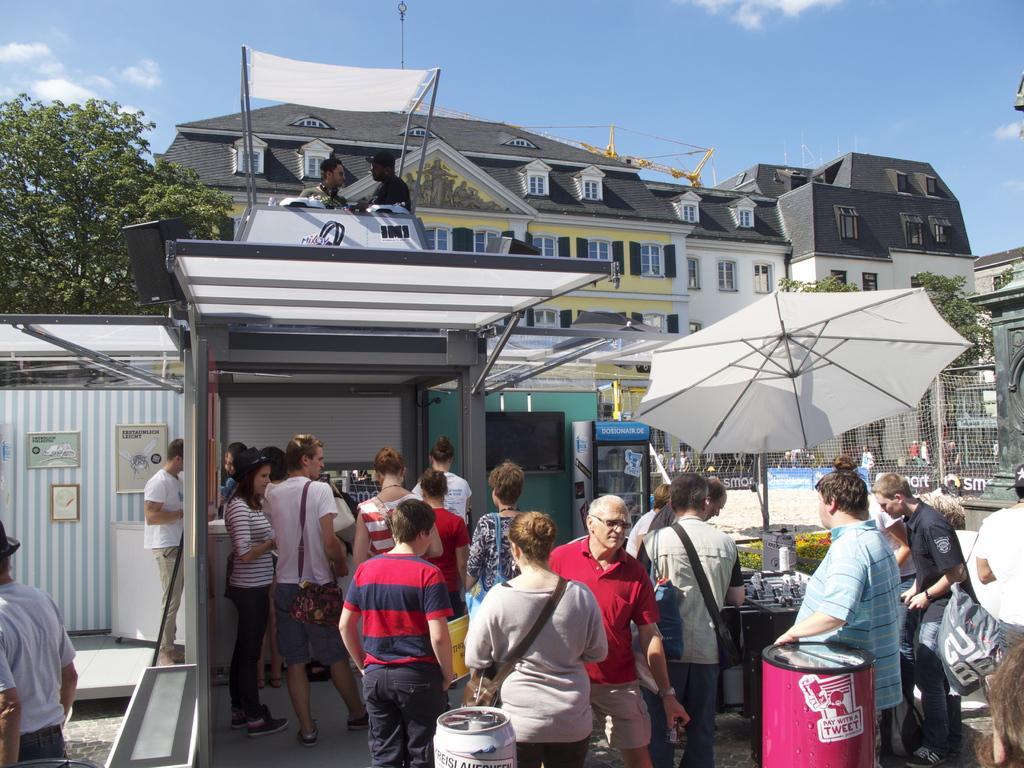In one or two sentences, can you explain what this image depicts? In this image there are group of persons standing and walking. In the front there are drums. In the center there is a tent which is white in colour and there is a table and on the table there objects and there is a refrigerator and in the background there are buildings, there is a fence and there is a tree and the sky is cloudy. On the top there is a shelter which is white in colour. 